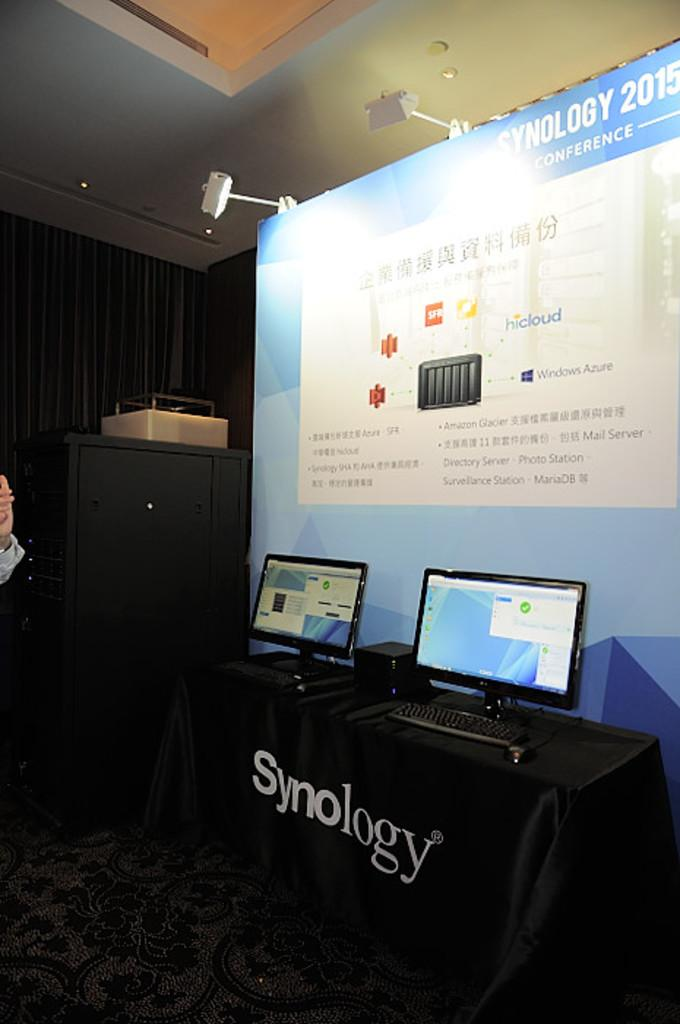<image>
Give a short and clear explanation of the subsequent image. A synology advertisement is in front of two monitors on display. 